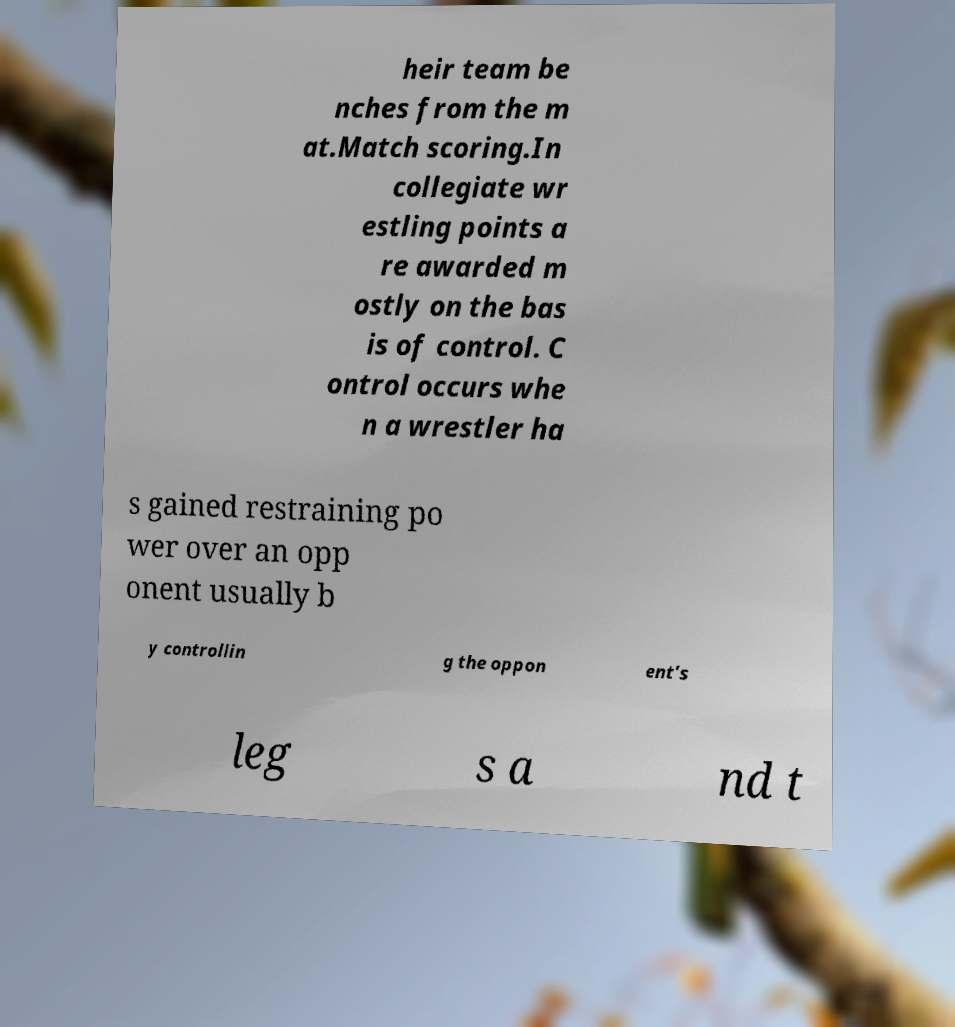Could you assist in decoding the text presented in this image and type it out clearly? heir team be nches from the m at.Match scoring.In collegiate wr estling points a re awarded m ostly on the bas is of control. C ontrol occurs whe n a wrestler ha s gained restraining po wer over an opp onent usually b y controllin g the oppon ent's leg s a nd t 